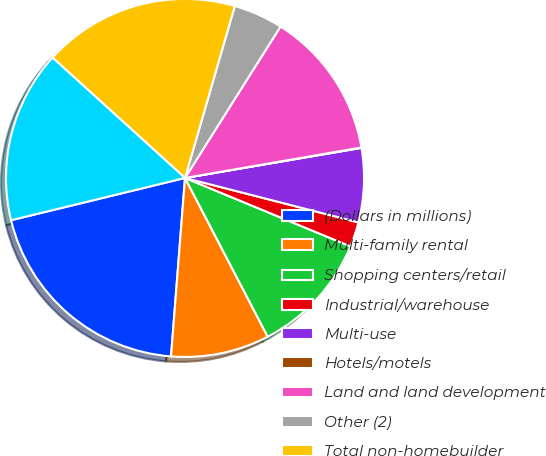Convert chart to OTSL. <chart><loc_0><loc_0><loc_500><loc_500><pie_chart><fcel>(Dollars in millions)<fcel>Multi-family rental<fcel>Shopping centers/retail<fcel>Industrial/warehouse<fcel>Multi-use<fcel>Hotels/motels<fcel>Land and land development<fcel>Other (2)<fcel>Total non-homebuilder<fcel>Commercial real estate -<nl><fcel>19.96%<fcel>8.89%<fcel>11.11%<fcel>2.25%<fcel>6.68%<fcel>0.04%<fcel>13.32%<fcel>4.47%<fcel>17.75%<fcel>15.53%<nl></chart> 